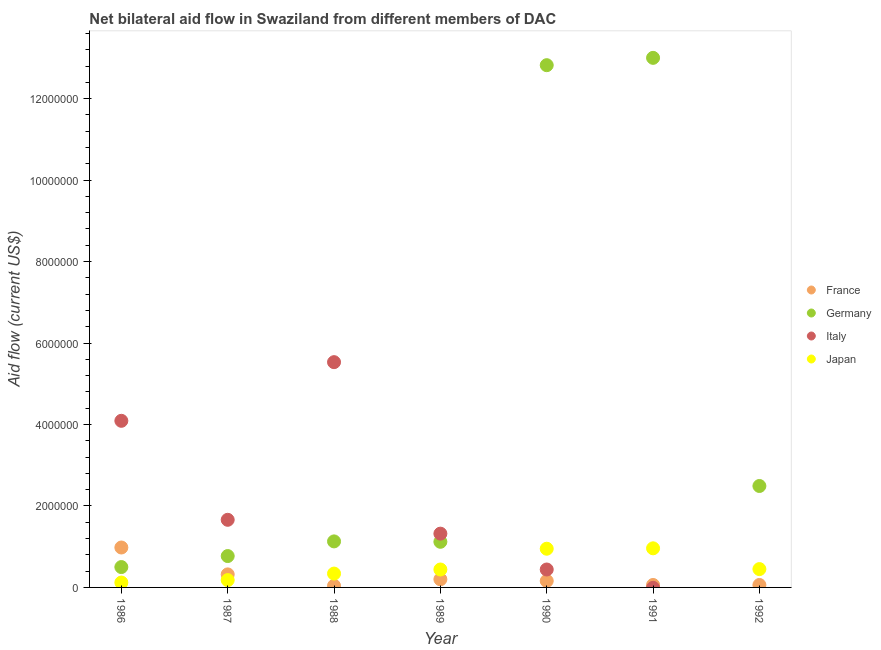How many different coloured dotlines are there?
Your answer should be very brief. 4. Is the number of dotlines equal to the number of legend labels?
Provide a succinct answer. No. What is the amount of aid given by italy in 1990?
Give a very brief answer. 4.40e+05. Across all years, what is the maximum amount of aid given by italy?
Make the answer very short. 5.53e+06. Across all years, what is the minimum amount of aid given by italy?
Offer a very short reply. 0. In which year was the amount of aid given by germany maximum?
Offer a very short reply. 1991. What is the total amount of aid given by japan in the graph?
Make the answer very short. 3.44e+06. What is the difference between the amount of aid given by france in 1987 and that in 1991?
Your response must be concise. 2.60e+05. What is the difference between the amount of aid given by france in 1990 and the amount of aid given by germany in 1992?
Provide a short and direct response. -2.33e+06. What is the average amount of aid given by germany per year?
Your response must be concise. 4.55e+06. In the year 1990, what is the difference between the amount of aid given by japan and amount of aid given by italy?
Keep it short and to the point. 5.10e+05. What is the ratio of the amount of aid given by france in 1988 to that in 1991?
Your response must be concise. 0.67. Is the amount of aid given by japan in 1986 less than that in 1991?
Offer a terse response. Yes. Is the difference between the amount of aid given by germany in 1986 and 1988 greater than the difference between the amount of aid given by japan in 1986 and 1988?
Provide a succinct answer. No. What is the difference between the highest and the second highest amount of aid given by japan?
Provide a succinct answer. 10000. What is the difference between the highest and the lowest amount of aid given by france?
Offer a very short reply. 9.40e+05. Is it the case that in every year, the sum of the amount of aid given by italy and amount of aid given by germany is greater than the sum of amount of aid given by japan and amount of aid given by france?
Offer a very short reply. Yes. Is it the case that in every year, the sum of the amount of aid given by france and amount of aid given by germany is greater than the amount of aid given by italy?
Your answer should be very brief. No. Does the amount of aid given by france monotonically increase over the years?
Your response must be concise. No. Does the graph contain grids?
Provide a short and direct response. No. Where does the legend appear in the graph?
Make the answer very short. Center right. What is the title of the graph?
Offer a very short reply. Net bilateral aid flow in Swaziland from different members of DAC. What is the label or title of the Y-axis?
Your answer should be very brief. Aid flow (current US$). What is the Aid flow (current US$) of France in 1986?
Keep it short and to the point. 9.80e+05. What is the Aid flow (current US$) in Italy in 1986?
Give a very brief answer. 4.09e+06. What is the Aid flow (current US$) in Japan in 1986?
Your response must be concise. 1.20e+05. What is the Aid flow (current US$) in France in 1987?
Keep it short and to the point. 3.20e+05. What is the Aid flow (current US$) in Germany in 1987?
Your answer should be very brief. 7.70e+05. What is the Aid flow (current US$) in Italy in 1987?
Offer a terse response. 1.66e+06. What is the Aid flow (current US$) of Germany in 1988?
Provide a short and direct response. 1.13e+06. What is the Aid flow (current US$) in Italy in 1988?
Provide a short and direct response. 5.53e+06. What is the Aid flow (current US$) of Germany in 1989?
Offer a very short reply. 1.12e+06. What is the Aid flow (current US$) in Italy in 1989?
Make the answer very short. 1.32e+06. What is the Aid flow (current US$) of Germany in 1990?
Offer a very short reply. 1.28e+07. What is the Aid flow (current US$) in Japan in 1990?
Provide a succinct answer. 9.50e+05. What is the Aid flow (current US$) in Germany in 1991?
Give a very brief answer. 1.30e+07. What is the Aid flow (current US$) in Italy in 1991?
Provide a succinct answer. 0. What is the Aid flow (current US$) in Japan in 1991?
Give a very brief answer. 9.60e+05. What is the Aid flow (current US$) of France in 1992?
Your answer should be very brief. 6.00e+04. What is the Aid flow (current US$) in Germany in 1992?
Offer a terse response. 2.49e+06. What is the Aid flow (current US$) of Japan in 1992?
Your response must be concise. 4.50e+05. Across all years, what is the maximum Aid flow (current US$) of France?
Ensure brevity in your answer.  9.80e+05. Across all years, what is the maximum Aid flow (current US$) of Germany?
Make the answer very short. 1.30e+07. Across all years, what is the maximum Aid flow (current US$) in Italy?
Keep it short and to the point. 5.53e+06. Across all years, what is the maximum Aid flow (current US$) in Japan?
Offer a very short reply. 9.60e+05. Across all years, what is the minimum Aid flow (current US$) in France?
Offer a terse response. 4.00e+04. Across all years, what is the minimum Aid flow (current US$) of Germany?
Provide a succinct answer. 5.00e+05. Across all years, what is the minimum Aid flow (current US$) of Italy?
Your answer should be compact. 0. What is the total Aid flow (current US$) in France in the graph?
Your answer should be compact. 1.82e+06. What is the total Aid flow (current US$) of Germany in the graph?
Keep it short and to the point. 3.18e+07. What is the total Aid flow (current US$) in Italy in the graph?
Your response must be concise. 1.30e+07. What is the total Aid flow (current US$) of Japan in the graph?
Offer a terse response. 3.44e+06. What is the difference between the Aid flow (current US$) of Italy in 1986 and that in 1987?
Provide a short and direct response. 2.43e+06. What is the difference between the Aid flow (current US$) in Japan in 1986 and that in 1987?
Keep it short and to the point. -6.00e+04. What is the difference between the Aid flow (current US$) in France in 1986 and that in 1988?
Ensure brevity in your answer.  9.40e+05. What is the difference between the Aid flow (current US$) of Germany in 1986 and that in 1988?
Ensure brevity in your answer.  -6.30e+05. What is the difference between the Aid flow (current US$) in Italy in 1986 and that in 1988?
Give a very brief answer. -1.44e+06. What is the difference between the Aid flow (current US$) in France in 1986 and that in 1989?
Provide a short and direct response. 7.80e+05. What is the difference between the Aid flow (current US$) in Germany in 1986 and that in 1989?
Your answer should be very brief. -6.20e+05. What is the difference between the Aid flow (current US$) of Italy in 1986 and that in 1989?
Give a very brief answer. 2.77e+06. What is the difference between the Aid flow (current US$) in Japan in 1986 and that in 1989?
Offer a terse response. -3.20e+05. What is the difference between the Aid flow (current US$) in France in 1986 and that in 1990?
Your answer should be compact. 8.20e+05. What is the difference between the Aid flow (current US$) in Germany in 1986 and that in 1990?
Provide a succinct answer. -1.23e+07. What is the difference between the Aid flow (current US$) in Italy in 1986 and that in 1990?
Ensure brevity in your answer.  3.65e+06. What is the difference between the Aid flow (current US$) of Japan in 1986 and that in 1990?
Provide a succinct answer. -8.30e+05. What is the difference between the Aid flow (current US$) in France in 1986 and that in 1991?
Your response must be concise. 9.20e+05. What is the difference between the Aid flow (current US$) of Germany in 1986 and that in 1991?
Ensure brevity in your answer.  -1.25e+07. What is the difference between the Aid flow (current US$) in Japan in 1986 and that in 1991?
Your answer should be very brief. -8.40e+05. What is the difference between the Aid flow (current US$) in France in 1986 and that in 1992?
Your response must be concise. 9.20e+05. What is the difference between the Aid flow (current US$) in Germany in 1986 and that in 1992?
Offer a very short reply. -1.99e+06. What is the difference between the Aid flow (current US$) of Japan in 1986 and that in 1992?
Provide a succinct answer. -3.30e+05. What is the difference between the Aid flow (current US$) of Germany in 1987 and that in 1988?
Make the answer very short. -3.60e+05. What is the difference between the Aid flow (current US$) in Italy in 1987 and that in 1988?
Make the answer very short. -3.87e+06. What is the difference between the Aid flow (current US$) in France in 1987 and that in 1989?
Offer a very short reply. 1.20e+05. What is the difference between the Aid flow (current US$) of Germany in 1987 and that in 1989?
Your response must be concise. -3.50e+05. What is the difference between the Aid flow (current US$) in Italy in 1987 and that in 1989?
Offer a very short reply. 3.40e+05. What is the difference between the Aid flow (current US$) of Japan in 1987 and that in 1989?
Keep it short and to the point. -2.60e+05. What is the difference between the Aid flow (current US$) in France in 1987 and that in 1990?
Offer a very short reply. 1.60e+05. What is the difference between the Aid flow (current US$) of Germany in 1987 and that in 1990?
Offer a very short reply. -1.20e+07. What is the difference between the Aid flow (current US$) of Italy in 1987 and that in 1990?
Keep it short and to the point. 1.22e+06. What is the difference between the Aid flow (current US$) in Japan in 1987 and that in 1990?
Make the answer very short. -7.70e+05. What is the difference between the Aid flow (current US$) of Germany in 1987 and that in 1991?
Make the answer very short. -1.22e+07. What is the difference between the Aid flow (current US$) in Japan in 1987 and that in 1991?
Make the answer very short. -7.80e+05. What is the difference between the Aid flow (current US$) in France in 1987 and that in 1992?
Provide a succinct answer. 2.60e+05. What is the difference between the Aid flow (current US$) of Germany in 1987 and that in 1992?
Offer a very short reply. -1.72e+06. What is the difference between the Aid flow (current US$) in Japan in 1987 and that in 1992?
Your answer should be very brief. -2.70e+05. What is the difference between the Aid flow (current US$) in Germany in 1988 and that in 1989?
Your answer should be compact. 10000. What is the difference between the Aid flow (current US$) of Italy in 1988 and that in 1989?
Give a very brief answer. 4.21e+06. What is the difference between the Aid flow (current US$) in Germany in 1988 and that in 1990?
Offer a very short reply. -1.17e+07. What is the difference between the Aid flow (current US$) in Italy in 1988 and that in 1990?
Make the answer very short. 5.09e+06. What is the difference between the Aid flow (current US$) of Japan in 1988 and that in 1990?
Make the answer very short. -6.10e+05. What is the difference between the Aid flow (current US$) in France in 1988 and that in 1991?
Give a very brief answer. -2.00e+04. What is the difference between the Aid flow (current US$) of Germany in 1988 and that in 1991?
Make the answer very short. -1.19e+07. What is the difference between the Aid flow (current US$) in Japan in 1988 and that in 1991?
Offer a terse response. -6.20e+05. What is the difference between the Aid flow (current US$) of Germany in 1988 and that in 1992?
Your response must be concise. -1.36e+06. What is the difference between the Aid flow (current US$) of France in 1989 and that in 1990?
Ensure brevity in your answer.  4.00e+04. What is the difference between the Aid flow (current US$) of Germany in 1989 and that in 1990?
Offer a very short reply. -1.17e+07. What is the difference between the Aid flow (current US$) in Italy in 1989 and that in 1990?
Make the answer very short. 8.80e+05. What is the difference between the Aid flow (current US$) of Japan in 1989 and that in 1990?
Provide a short and direct response. -5.10e+05. What is the difference between the Aid flow (current US$) in France in 1989 and that in 1991?
Make the answer very short. 1.40e+05. What is the difference between the Aid flow (current US$) in Germany in 1989 and that in 1991?
Offer a terse response. -1.19e+07. What is the difference between the Aid flow (current US$) in Japan in 1989 and that in 1991?
Give a very brief answer. -5.20e+05. What is the difference between the Aid flow (current US$) of France in 1989 and that in 1992?
Provide a short and direct response. 1.40e+05. What is the difference between the Aid flow (current US$) in Germany in 1989 and that in 1992?
Provide a succinct answer. -1.37e+06. What is the difference between the Aid flow (current US$) of Germany in 1990 and that in 1991?
Offer a very short reply. -1.80e+05. What is the difference between the Aid flow (current US$) in Japan in 1990 and that in 1991?
Offer a terse response. -10000. What is the difference between the Aid flow (current US$) of Germany in 1990 and that in 1992?
Make the answer very short. 1.03e+07. What is the difference between the Aid flow (current US$) in France in 1991 and that in 1992?
Make the answer very short. 0. What is the difference between the Aid flow (current US$) of Germany in 1991 and that in 1992?
Your response must be concise. 1.05e+07. What is the difference between the Aid flow (current US$) of Japan in 1991 and that in 1992?
Your response must be concise. 5.10e+05. What is the difference between the Aid flow (current US$) in France in 1986 and the Aid flow (current US$) in Italy in 1987?
Keep it short and to the point. -6.80e+05. What is the difference between the Aid flow (current US$) of France in 1986 and the Aid flow (current US$) of Japan in 1987?
Your answer should be very brief. 8.00e+05. What is the difference between the Aid flow (current US$) of Germany in 1986 and the Aid flow (current US$) of Italy in 1987?
Offer a terse response. -1.16e+06. What is the difference between the Aid flow (current US$) in Italy in 1986 and the Aid flow (current US$) in Japan in 1987?
Provide a succinct answer. 3.91e+06. What is the difference between the Aid flow (current US$) of France in 1986 and the Aid flow (current US$) of Germany in 1988?
Your answer should be compact. -1.50e+05. What is the difference between the Aid flow (current US$) in France in 1986 and the Aid flow (current US$) in Italy in 1988?
Offer a terse response. -4.55e+06. What is the difference between the Aid flow (current US$) in France in 1986 and the Aid flow (current US$) in Japan in 1988?
Make the answer very short. 6.40e+05. What is the difference between the Aid flow (current US$) of Germany in 1986 and the Aid flow (current US$) of Italy in 1988?
Give a very brief answer. -5.03e+06. What is the difference between the Aid flow (current US$) in Italy in 1986 and the Aid flow (current US$) in Japan in 1988?
Your response must be concise. 3.75e+06. What is the difference between the Aid flow (current US$) of France in 1986 and the Aid flow (current US$) of Germany in 1989?
Offer a very short reply. -1.40e+05. What is the difference between the Aid flow (current US$) in France in 1986 and the Aid flow (current US$) in Italy in 1989?
Provide a succinct answer. -3.40e+05. What is the difference between the Aid flow (current US$) of France in 1986 and the Aid flow (current US$) of Japan in 1989?
Ensure brevity in your answer.  5.40e+05. What is the difference between the Aid flow (current US$) in Germany in 1986 and the Aid flow (current US$) in Italy in 1989?
Your answer should be compact. -8.20e+05. What is the difference between the Aid flow (current US$) in Germany in 1986 and the Aid flow (current US$) in Japan in 1989?
Your response must be concise. 6.00e+04. What is the difference between the Aid flow (current US$) of Italy in 1986 and the Aid flow (current US$) of Japan in 1989?
Make the answer very short. 3.65e+06. What is the difference between the Aid flow (current US$) in France in 1986 and the Aid flow (current US$) in Germany in 1990?
Make the answer very short. -1.18e+07. What is the difference between the Aid flow (current US$) in France in 1986 and the Aid flow (current US$) in Italy in 1990?
Keep it short and to the point. 5.40e+05. What is the difference between the Aid flow (current US$) in France in 1986 and the Aid flow (current US$) in Japan in 1990?
Provide a short and direct response. 3.00e+04. What is the difference between the Aid flow (current US$) of Germany in 1986 and the Aid flow (current US$) of Italy in 1990?
Your answer should be very brief. 6.00e+04. What is the difference between the Aid flow (current US$) in Germany in 1986 and the Aid flow (current US$) in Japan in 1990?
Offer a terse response. -4.50e+05. What is the difference between the Aid flow (current US$) in Italy in 1986 and the Aid flow (current US$) in Japan in 1990?
Your response must be concise. 3.14e+06. What is the difference between the Aid flow (current US$) in France in 1986 and the Aid flow (current US$) in Germany in 1991?
Keep it short and to the point. -1.20e+07. What is the difference between the Aid flow (current US$) in Germany in 1986 and the Aid flow (current US$) in Japan in 1991?
Ensure brevity in your answer.  -4.60e+05. What is the difference between the Aid flow (current US$) in Italy in 1986 and the Aid flow (current US$) in Japan in 1991?
Your answer should be very brief. 3.13e+06. What is the difference between the Aid flow (current US$) in France in 1986 and the Aid flow (current US$) in Germany in 1992?
Offer a very short reply. -1.51e+06. What is the difference between the Aid flow (current US$) of France in 1986 and the Aid flow (current US$) of Japan in 1992?
Your answer should be very brief. 5.30e+05. What is the difference between the Aid flow (current US$) in Italy in 1986 and the Aid flow (current US$) in Japan in 1992?
Your answer should be very brief. 3.64e+06. What is the difference between the Aid flow (current US$) of France in 1987 and the Aid flow (current US$) of Germany in 1988?
Ensure brevity in your answer.  -8.10e+05. What is the difference between the Aid flow (current US$) in France in 1987 and the Aid flow (current US$) in Italy in 1988?
Your response must be concise. -5.21e+06. What is the difference between the Aid flow (current US$) in Germany in 1987 and the Aid flow (current US$) in Italy in 1988?
Provide a succinct answer. -4.76e+06. What is the difference between the Aid flow (current US$) of Italy in 1987 and the Aid flow (current US$) of Japan in 1988?
Keep it short and to the point. 1.32e+06. What is the difference between the Aid flow (current US$) of France in 1987 and the Aid flow (current US$) of Germany in 1989?
Your response must be concise. -8.00e+05. What is the difference between the Aid flow (current US$) of Germany in 1987 and the Aid flow (current US$) of Italy in 1989?
Your response must be concise. -5.50e+05. What is the difference between the Aid flow (current US$) of Italy in 1987 and the Aid flow (current US$) of Japan in 1989?
Provide a short and direct response. 1.22e+06. What is the difference between the Aid flow (current US$) of France in 1987 and the Aid flow (current US$) of Germany in 1990?
Offer a very short reply. -1.25e+07. What is the difference between the Aid flow (current US$) of France in 1987 and the Aid flow (current US$) of Japan in 1990?
Your response must be concise. -6.30e+05. What is the difference between the Aid flow (current US$) in Italy in 1987 and the Aid flow (current US$) in Japan in 1990?
Your response must be concise. 7.10e+05. What is the difference between the Aid flow (current US$) in France in 1987 and the Aid flow (current US$) in Germany in 1991?
Your response must be concise. -1.27e+07. What is the difference between the Aid flow (current US$) in France in 1987 and the Aid flow (current US$) in Japan in 1991?
Ensure brevity in your answer.  -6.40e+05. What is the difference between the Aid flow (current US$) of France in 1987 and the Aid flow (current US$) of Germany in 1992?
Provide a short and direct response. -2.17e+06. What is the difference between the Aid flow (current US$) in France in 1987 and the Aid flow (current US$) in Japan in 1992?
Provide a short and direct response. -1.30e+05. What is the difference between the Aid flow (current US$) of Italy in 1987 and the Aid flow (current US$) of Japan in 1992?
Your answer should be very brief. 1.21e+06. What is the difference between the Aid flow (current US$) in France in 1988 and the Aid flow (current US$) in Germany in 1989?
Offer a very short reply. -1.08e+06. What is the difference between the Aid flow (current US$) of France in 1988 and the Aid flow (current US$) of Italy in 1989?
Provide a succinct answer. -1.28e+06. What is the difference between the Aid flow (current US$) of France in 1988 and the Aid flow (current US$) of Japan in 1989?
Make the answer very short. -4.00e+05. What is the difference between the Aid flow (current US$) in Germany in 1988 and the Aid flow (current US$) in Italy in 1989?
Give a very brief answer. -1.90e+05. What is the difference between the Aid flow (current US$) of Germany in 1988 and the Aid flow (current US$) of Japan in 1989?
Offer a very short reply. 6.90e+05. What is the difference between the Aid flow (current US$) in Italy in 1988 and the Aid flow (current US$) in Japan in 1989?
Your answer should be very brief. 5.09e+06. What is the difference between the Aid flow (current US$) of France in 1988 and the Aid flow (current US$) of Germany in 1990?
Your response must be concise. -1.28e+07. What is the difference between the Aid flow (current US$) in France in 1988 and the Aid flow (current US$) in Italy in 1990?
Make the answer very short. -4.00e+05. What is the difference between the Aid flow (current US$) of France in 1988 and the Aid flow (current US$) of Japan in 1990?
Offer a very short reply. -9.10e+05. What is the difference between the Aid flow (current US$) in Germany in 1988 and the Aid flow (current US$) in Italy in 1990?
Give a very brief answer. 6.90e+05. What is the difference between the Aid flow (current US$) of Italy in 1988 and the Aid flow (current US$) of Japan in 1990?
Offer a very short reply. 4.58e+06. What is the difference between the Aid flow (current US$) in France in 1988 and the Aid flow (current US$) in Germany in 1991?
Give a very brief answer. -1.30e+07. What is the difference between the Aid flow (current US$) of France in 1988 and the Aid flow (current US$) of Japan in 1991?
Give a very brief answer. -9.20e+05. What is the difference between the Aid flow (current US$) of Germany in 1988 and the Aid flow (current US$) of Japan in 1991?
Ensure brevity in your answer.  1.70e+05. What is the difference between the Aid flow (current US$) of Italy in 1988 and the Aid flow (current US$) of Japan in 1991?
Offer a terse response. 4.57e+06. What is the difference between the Aid flow (current US$) in France in 1988 and the Aid flow (current US$) in Germany in 1992?
Offer a terse response. -2.45e+06. What is the difference between the Aid flow (current US$) in France in 1988 and the Aid flow (current US$) in Japan in 1992?
Offer a very short reply. -4.10e+05. What is the difference between the Aid flow (current US$) of Germany in 1988 and the Aid flow (current US$) of Japan in 1992?
Give a very brief answer. 6.80e+05. What is the difference between the Aid flow (current US$) of Italy in 1988 and the Aid flow (current US$) of Japan in 1992?
Ensure brevity in your answer.  5.08e+06. What is the difference between the Aid flow (current US$) of France in 1989 and the Aid flow (current US$) of Germany in 1990?
Offer a terse response. -1.26e+07. What is the difference between the Aid flow (current US$) of France in 1989 and the Aid flow (current US$) of Italy in 1990?
Offer a terse response. -2.40e+05. What is the difference between the Aid flow (current US$) in France in 1989 and the Aid flow (current US$) in Japan in 1990?
Ensure brevity in your answer.  -7.50e+05. What is the difference between the Aid flow (current US$) in Germany in 1989 and the Aid flow (current US$) in Italy in 1990?
Your answer should be compact. 6.80e+05. What is the difference between the Aid flow (current US$) of Germany in 1989 and the Aid flow (current US$) of Japan in 1990?
Offer a very short reply. 1.70e+05. What is the difference between the Aid flow (current US$) of Italy in 1989 and the Aid flow (current US$) of Japan in 1990?
Ensure brevity in your answer.  3.70e+05. What is the difference between the Aid flow (current US$) of France in 1989 and the Aid flow (current US$) of Germany in 1991?
Offer a very short reply. -1.28e+07. What is the difference between the Aid flow (current US$) in France in 1989 and the Aid flow (current US$) in Japan in 1991?
Offer a terse response. -7.60e+05. What is the difference between the Aid flow (current US$) in Germany in 1989 and the Aid flow (current US$) in Japan in 1991?
Your answer should be very brief. 1.60e+05. What is the difference between the Aid flow (current US$) in France in 1989 and the Aid flow (current US$) in Germany in 1992?
Provide a short and direct response. -2.29e+06. What is the difference between the Aid flow (current US$) of Germany in 1989 and the Aid flow (current US$) of Japan in 1992?
Provide a short and direct response. 6.70e+05. What is the difference between the Aid flow (current US$) of Italy in 1989 and the Aid flow (current US$) of Japan in 1992?
Your answer should be compact. 8.70e+05. What is the difference between the Aid flow (current US$) in France in 1990 and the Aid flow (current US$) in Germany in 1991?
Offer a very short reply. -1.28e+07. What is the difference between the Aid flow (current US$) in France in 1990 and the Aid flow (current US$) in Japan in 1991?
Provide a succinct answer. -8.00e+05. What is the difference between the Aid flow (current US$) in Germany in 1990 and the Aid flow (current US$) in Japan in 1991?
Make the answer very short. 1.19e+07. What is the difference between the Aid flow (current US$) of Italy in 1990 and the Aid flow (current US$) of Japan in 1991?
Give a very brief answer. -5.20e+05. What is the difference between the Aid flow (current US$) of France in 1990 and the Aid flow (current US$) of Germany in 1992?
Provide a succinct answer. -2.33e+06. What is the difference between the Aid flow (current US$) in France in 1990 and the Aid flow (current US$) in Japan in 1992?
Keep it short and to the point. -2.90e+05. What is the difference between the Aid flow (current US$) in Germany in 1990 and the Aid flow (current US$) in Japan in 1992?
Provide a succinct answer. 1.24e+07. What is the difference between the Aid flow (current US$) in Italy in 1990 and the Aid flow (current US$) in Japan in 1992?
Keep it short and to the point. -10000. What is the difference between the Aid flow (current US$) in France in 1991 and the Aid flow (current US$) in Germany in 1992?
Ensure brevity in your answer.  -2.43e+06. What is the difference between the Aid flow (current US$) of France in 1991 and the Aid flow (current US$) of Japan in 1992?
Give a very brief answer. -3.90e+05. What is the difference between the Aid flow (current US$) of Germany in 1991 and the Aid flow (current US$) of Japan in 1992?
Make the answer very short. 1.26e+07. What is the average Aid flow (current US$) in Germany per year?
Make the answer very short. 4.55e+06. What is the average Aid flow (current US$) of Italy per year?
Offer a terse response. 1.86e+06. What is the average Aid flow (current US$) of Japan per year?
Offer a very short reply. 4.91e+05. In the year 1986, what is the difference between the Aid flow (current US$) in France and Aid flow (current US$) in Italy?
Your answer should be compact. -3.11e+06. In the year 1986, what is the difference between the Aid flow (current US$) in France and Aid flow (current US$) in Japan?
Your answer should be very brief. 8.60e+05. In the year 1986, what is the difference between the Aid flow (current US$) in Germany and Aid flow (current US$) in Italy?
Keep it short and to the point. -3.59e+06. In the year 1986, what is the difference between the Aid flow (current US$) in Italy and Aid flow (current US$) in Japan?
Make the answer very short. 3.97e+06. In the year 1987, what is the difference between the Aid flow (current US$) of France and Aid flow (current US$) of Germany?
Your response must be concise. -4.50e+05. In the year 1987, what is the difference between the Aid flow (current US$) of France and Aid flow (current US$) of Italy?
Keep it short and to the point. -1.34e+06. In the year 1987, what is the difference between the Aid flow (current US$) in Germany and Aid flow (current US$) in Italy?
Provide a short and direct response. -8.90e+05. In the year 1987, what is the difference between the Aid flow (current US$) in Germany and Aid flow (current US$) in Japan?
Your answer should be very brief. 5.90e+05. In the year 1987, what is the difference between the Aid flow (current US$) in Italy and Aid flow (current US$) in Japan?
Offer a very short reply. 1.48e+06. In the year 1988, what is the difference between the Aid flow (current US$) in France and Aid flow (current US$) in Germany?
Make the answer very short. -1.09e+06. In the year 1988, what is the difference between the Aid flow (current US$) in France and Aid flow (current US$) in Italy?
Your response must be concise. -5.49e+06. In the year 1988, what is the difference between the Aid flow (current US$) of Germany and Aid flow (current US$) of Italy?
Ensure brevity in your answer.  -4.40e+06. In the year 1988, what is the difference between the Aid flow (current US$) in Germany and Aid flow (current US$) in Japan?
Make the answer very short. 7.90e+05. In the year 1988, what is the difference between the Aid flow (current US$) of Italy and Aid flow (current US$) of Japan?
Keep it short and to the point. 5.19e+06. In the year 1989, what is the difference between the Aid flow (current US$) in France and Aid flow (current US$) in Germany?
Offer a very short reply. -9.20e+05. In the year 1989, what is the difference between the Aid flow (current US$) in France and Aid flow (current US$) in Italy?
Provide a succinct answer. -1.12e+06. In the year 1989, what is the difference between the Aid flow (current US$) in Germany and Aid flow (current US$) in Italy?
Provide a short and direct response. -2.00e+05. In the year 1989, what is the difference between the Aid flow (current US$) of Germany and Aid flow (current US$) of Japan?
Your answer should be very brief. 6.80e+05. In the year 1989, what is the difference between the Aid flow (current US$) in Italy and Aid flow (current US$) in Japan?
Ensure brevity in your answer.  8.80e+05. In the year 1990, what is the difference between the Aid flow (current US$) in France and Aid flow (current US$) in Germany?
Provide a succinct answer. -1.27e+07. In the year 1990, what is the difference between the Aid flow (current US$) of France and Aid flow (current US$) of Italy?
Make the answer very short. -2.80e+05. In the year 1990, what is the difference between the Aid flow (current US$) of France and Aid flow (current US$) of Japan?
Keep it short and to the point. -7.90e+05. In the year 1990, what is the difference between the Aid flow (current US$) of Germany and Aid flow (current US$) of Italy?
Your answer should be compact. 1.24e+07. In the year 1990, what is the difference between the Aid flow (current US$) in Germany and Aid flow (current US$) in Japan?
Provide a succinct answer. 1.19e+07. In the year 1990, what is the difference between the Aid flow (current US$) in Italy and Aid flow (current US$) in Japan?
Keep it short and to the point. -5.10e+05. In the year 1991, what is the difference between the Aid flow (current US$) of France and Aid flow (current US$) of Germany?
Your answer should be very brief. -1.29e+07. In the year 1991, what is the difference between the Aid flow (current US$) of France and Aid flow (current US$) of Japan?
Offer a very short reply. -9.00e+05. In the year 1991, what is the difference between the Aid flow (current US$) of Germany and Aid flow (current US$) of Japan?
Offer a terse response. 1.20e+07. In the year 1992, what is the difference between the Aid flow (current US$) in France and Aid flow (current US$) in Germany?
Your answer should be compact. -2.43e+06. In the year 1992, what is the difference between the Aid flow (current US$) of France and Aid flow (current US$) of Japan?
Keep it short and to the point. -3.90e+05. In the year 1992, what is the difference between the Aid flow (current US$) in Germany and Aid flow (current US$) in Japan?
Your answer should be very brief. 2.04e+06. What is the ratio of the Aid flow (current US$) in France in 1986 to that in 1987?
Ensure brevity in your answer.  3.06. What is the ratio of the Aid flow (current US$) in Germany in 1986 to that in 1987?
Ensure brevity in your answer.  0.65. What is the ratio of the Aid flow (current US$) of Italy in 1986 to that in 1987?
Offer a very short reply. 2.46. What is the ratio of the Aid flow (current US$) in Germany in 1986 to that in 1988?
Ensure brevity in your answer.  0.44. What is the ratio of the Aid flow (current US$) of Italy in 1986 to that in 1988?
Ensure brevity in your answer.  0.74. What is the ratio of the Aid flow (current US$) of Japan in 1986 to that in 1988?
Ensure brevity in your answer.  0.35. What is the ratio of the Aid flow (current US$) of Germany in 1986 to that in 1989?
Keep it short and to the point. 0.45. What is the ratio of the Aid flow (current US$) of Italy in 1986 to that in 1989?
Give a very brief answer. 3.1. What is the ratio of the Aid flow (current US$) in Japan in 1986 to that in 1989?
Your answer should be very brief. 0.27. What is the ratio of the Aid flow (current US$) in France in 1986 to that in 1990?
Offer a very short reply. 6.12. What is the ratio of the Aid flow (current US$) in Germany in 1986 to that in 1990?
Offer a very short reply. 0.04. What is the ratio of the Aid flow (current US$) in Italy in 1986 to that in 1990?
Offer a very short reply. 9.3. What is the ratio of the Aid flow (current US$) of Japan in 1986 to that in 1990?
Offer a very short reply. 0.13. What is the ratio of the Aid flow (current US$) of France in 1986 to that in 1991?
Give a very brief answer. 16.33. What is the ratio of the Aid flow (current US$) in Germany in 1986 to that in 1991?
Ensure brevity in your answer.  0.04. What is the ratio of the Aid flow (current US$) in France in 1986 to that in 1992?
Provide a short and direct response. 16.33. What is the ratio of the Aid flow (current US$) of Germany in 1986 to that in 1992?
Offer a very short reply. 0.2. What is the ratio of the Aid flow (current US$) of Japan in 1986 to that in 1992?
Keep it short and to the point. 0.27. What is the ratio of the Aid flow (current US$) of France in 1987 to that in 1988?
Ensure brevity in your answer.  8. What is the ratio of the Aid flow (current US$) in Germany in 1987 to that in 1988?
Keep it short and to the point. 0.68. What is the ratio of the Aid flow (current US$) of Italy in 1987 to that in 1988?
Provide a succinct answer. 0.3. What is the ratio of the Aid flow (current US$) of Japan in 1987 to that in 1988?
Offer a terse response. 0.53. What is the ratio of the Aid flow (current US$) of France in 1987 to that in 1989?
Your response must be concise. 1.6. What is the ratio of the Aid flow (current US$) in Germany in 1987 to that in 1989?
Provide a succinct answer. 0.69. What is the ratio of the Aid flow (current US$) in Italy in 1987 to that in 1989?
Make the answer very short. 1.26. What is the ratio of the Aid flow (current US$) in Japan in 1987 to that in 1989?
Provide a short and direct response. 0.41. What is the ratio of the Aid flow (current US$) of Germany in 1987 to that in 1990?
Offer a terse response. 0.06. What is the ratio of the Aid flow (current US$) of Italy in 1987 to that in 1990?
Offer a terse response. 3.77. What is the ratio of the Aid flow (current US$) of Japan in 1987 to that in 1990?
Provide a succinct answer. 0.19. What is the ratio of the Aid flow (current US$) of France in 1987 to that in 1991?
Your answer should be compact. 5.33. What is the ratio of the Aid flow (current US$) of Germany in 1987 to that in 1991?
Ensure brevity in your answer.  0.06. What is the ratio of the Aid flow (current US$) of Japan in 1987 to that in 1991?
Your answer should be very brief. 0.19. What is the ratio of the Aid flow (current US$) of France in 1987 to that in 1992?
Your response must be concise. 5.33. What is the ratio of the Aid flow (current US$) in Germany in 1987 to that in 1992?
Make the answer very short. 0.31. What is the ratio of the Aid flow (current US$) of Germany in 1988 to that in 1989?
Offer a terse response. 1.01. What is the ratio of the Aid flow (current US$) of Italy in 1988 to that in 1989?
Keep it short and to the point. 4.19. What is the ratio of the Aid flow (current US$) in Japan in 1988 to that in 1989?
Your answer should be very brief. 0.77. What is the ratio of the Aid flow (current US$) in Germany in 1988 to that in 1990?
Offer a terse response. 0.09. What is the ratio of the Aid flow (current US$) in Italy in 1988 to that in 1990?
Your response must be concise. 12.57. What is the ratio of the Aid flow (current US$) in Japan in 1988 to that in 1990?
Provide a succinct answer. 0.36. What is the ratio of the Aid flow (current US$) in Germany in 1988 to that in 1991?
Your response must be concise. 0.09. What is the ratio of the Aid flow (current US$) of Japan in 1988 to that in 1991?
Ensure brevity in your answer.  0.35. What is the ratio of the Aid flow (current US$) of Germany in 1988 to that in 1992?
Your response must be concise. 0.45. What is the ratio of the Aid flow (current US$) of Japan in 1988 to that in 1992?
Provide a succinct answer. 0.76. What is the ratio of the Aid flow (current US$) in France in 1989 to that in 1990?
Keep it short and to the point. 1.25. What is the ratio of the Aid flow (current US$) of Germany in 1989 to that in 1990?
Provide a succinct answer. 0.09. What is the ratio of the Aid flow (current US$) of Japan in 1989 to that in 1990?
Give a very brief answer. 0.46. What is the ratio of the Aid flow (current US$) in France in 1989 to that in 1991?
Give a very brief answer. 3.33. What is the ratio of the Aid flow (current US$) of Germany in 1989 to that in 1991?
Provide a succinct answer. 0.09. What is the ratio of the Aid flow (current US$) of Japan in 1989 to that in 1991?
Your answer should be compact. 0.46. What is the ratio of the Aid flow (current US$) of Germany in 1989 to that in 1992?
Your response must be concise. 0.45. What is the ratio of the Aid flow (current US$) of Japan in 1989 to that in 1992?
Your answer should be very brief. 0.98. What is the ratio of the Aid flow (current US$) of France in 1990 to that in 1991?
Your response must be concise. 2.67. What is the ratio of the Aid flow (current US$) of Germany in 1990 to that in 1991?
Your answer should be very brief. 0.99. What is the ratio of the Aid flow (current US$) of France in 1990 to that in 1992?
Your response must be concise. 2.67. What is the ratio of the Aid flow (current US$) of Germany in 1990 to that in 1992?
Make the answer very short. 5.15. What is the ratio of the Aid flow (current US$) of Japan in 1990 to that in 1992?
Ensure brevity in your answer.  2.11. What is the ratio of the Aid flow (current US$) in Germany in 1991 to that in 1992?
Offer a terse response. 5.22. What is the ratio of the Aid flow (current US$) of Japan in 1991 to that in 1992?
Your response must be concise. 2.13. What is the difference between the highest and the second highest Aid flow (current US$) in Italy?
Ensure brevity in your answer.  1.44e+06. What is the difference between the highest and the second highest Aid flow (current US$) in Japan?
Give a very brief answer. 10000. What is the difference between the highest and the lowest Aid flow (current US$) of France?
Your response must be concise. 9.40e+05. What is the difference between the highest and the lowest Aid flow (current US$) in Germany?
Your response must be concise. 1.25e+07. What is the difference between the highest and the lowest Aid flow (current US$) of Italy?
Give a very brief answer. 5.53e+06. What is the difference between the highest and the lowest Aid flow (current US$) in Japan?
Offer a terse response. 8.40e+05. 